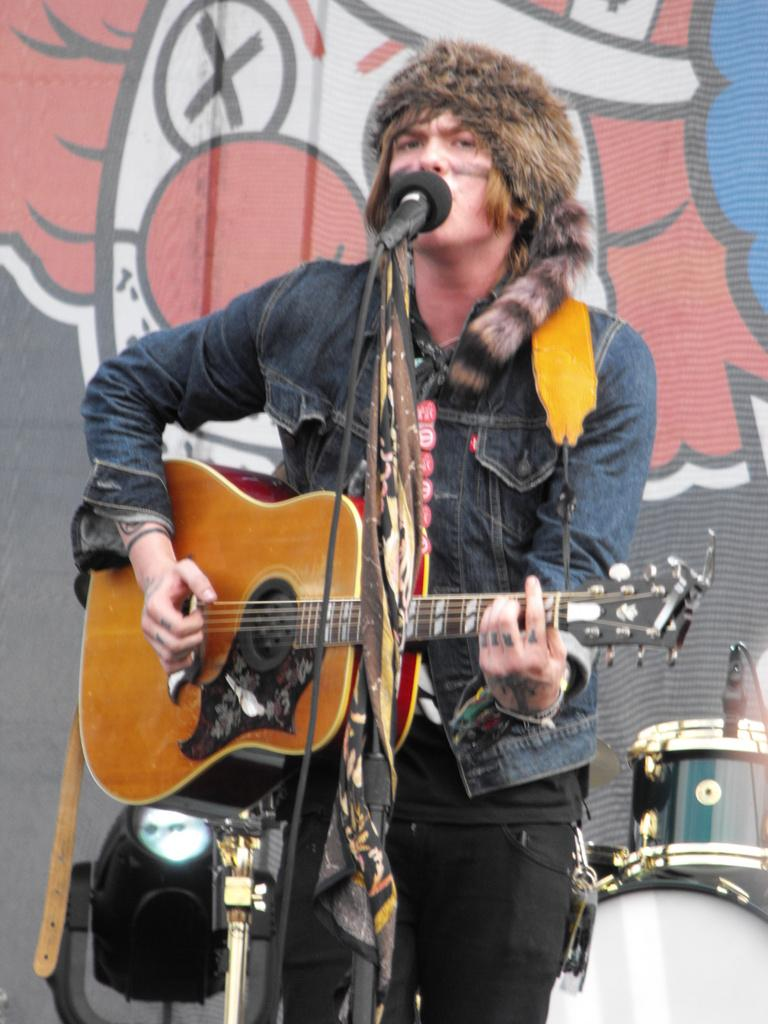Who is the person in the image? There is a man in the image. What is the man holding in the image? The man is holding a guitar. What is the man doing with the guitar? The man is playing the guitar. What other musical instruments can be seen in the background? There are electronic drums in the background. What else is visible in the background besides the drums? There are lights and wall paint in the background. What type of straw is the man using to play the guitar in the image? There is no straw present in the image; the man is playing the guitar with his hands. 